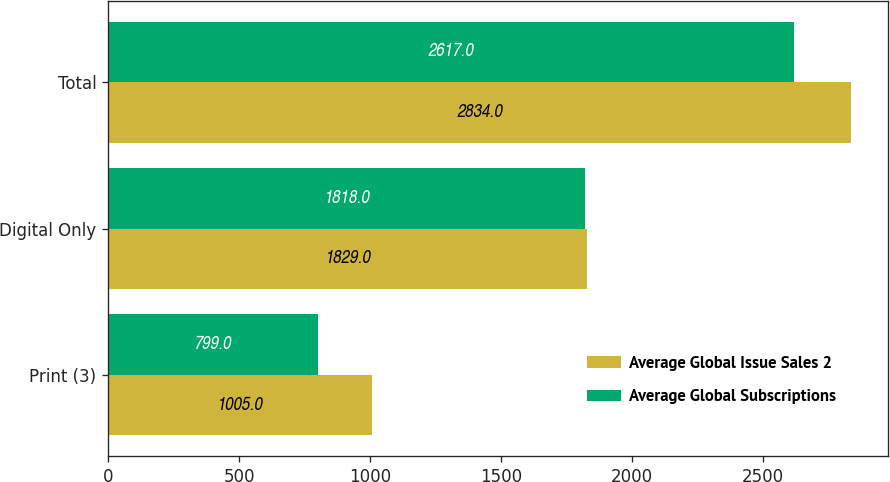Convert chart to OTSL. <chart><loc_0><loc_0><loc_500><loc_500><stacked_bar_chart><ecel><fcel>Print (3)<fcel>Digital Only<fcel>Total<nl><fcel>Average Global Issue Sales 2<fcel>1005<fcel>1829<fcel>2834<nl><fcel>Average Global Subscriptions<fcel>799<fcel>1818<fcel>2617<nl></chart> 